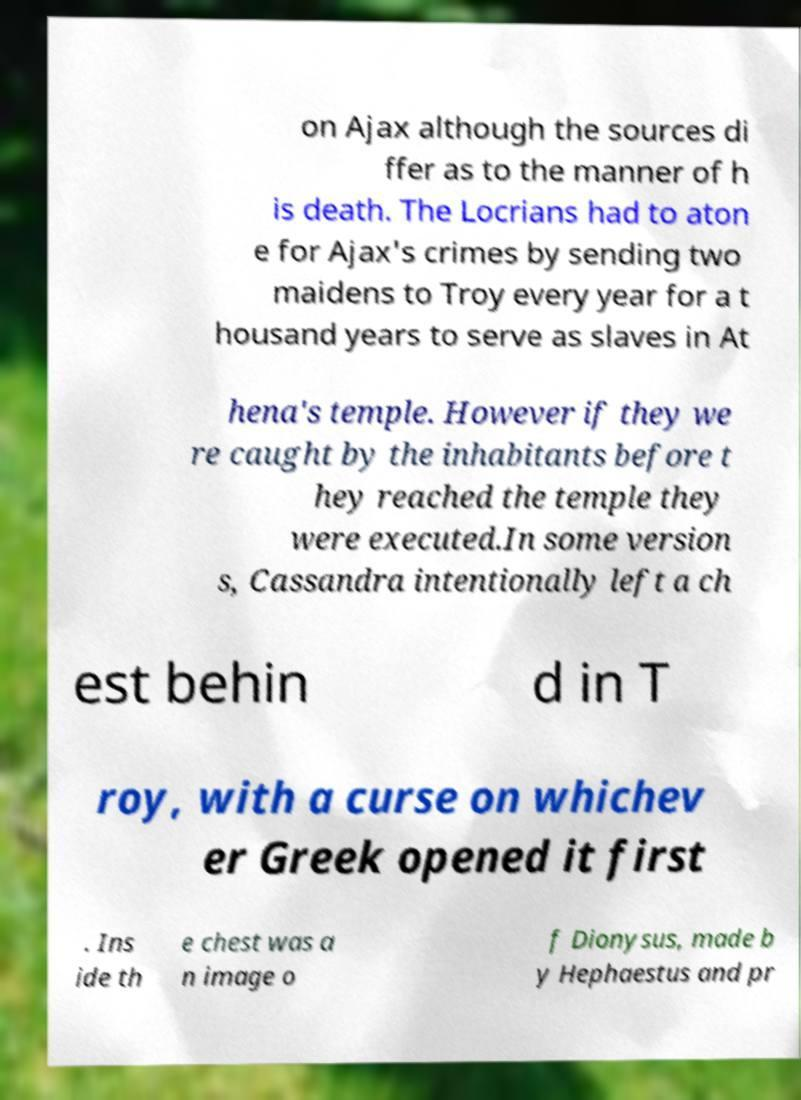For documentation purposes, I need the text within this image transcribed. Could you provide that? on Ajax although the sources di ffer as to the manner of h is death. The Locrians had to aton e for Ajax's crimes by sending two maidens to Troy every year for a t housand years to serve as slaves in At hena's temple. However if they we re caught by the inhabitants before t hey reached the temple they were executed.In some version s, Cassandra intentionally left a ch est behin d in T roy, with a curse on whichev er Greek opened it first . Ins ide th e chest was a n image o f Dionysus, made b y Hephaestus and pr 